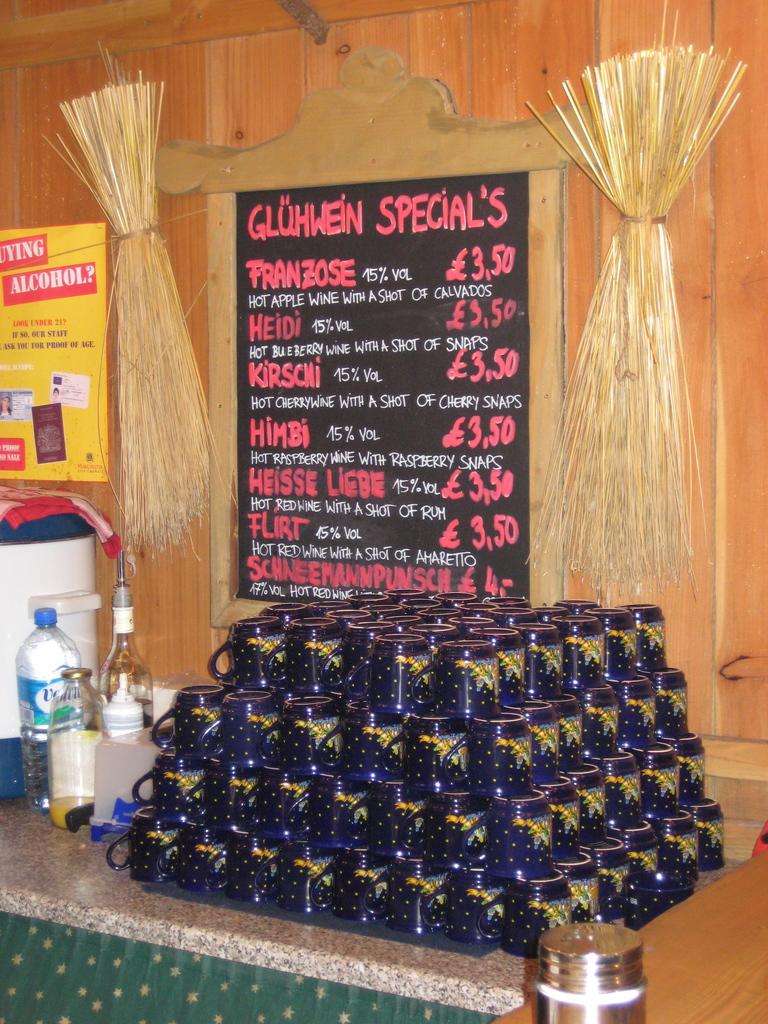What is the price of the first item on the menu?
Provide a short and direct response. 3.50. 